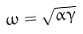Convert formula to latex. <formula><loc_0><loc_0><loc_500><loc_500>\omega = { \sqrt { \alpha \gamma } }</formula> 